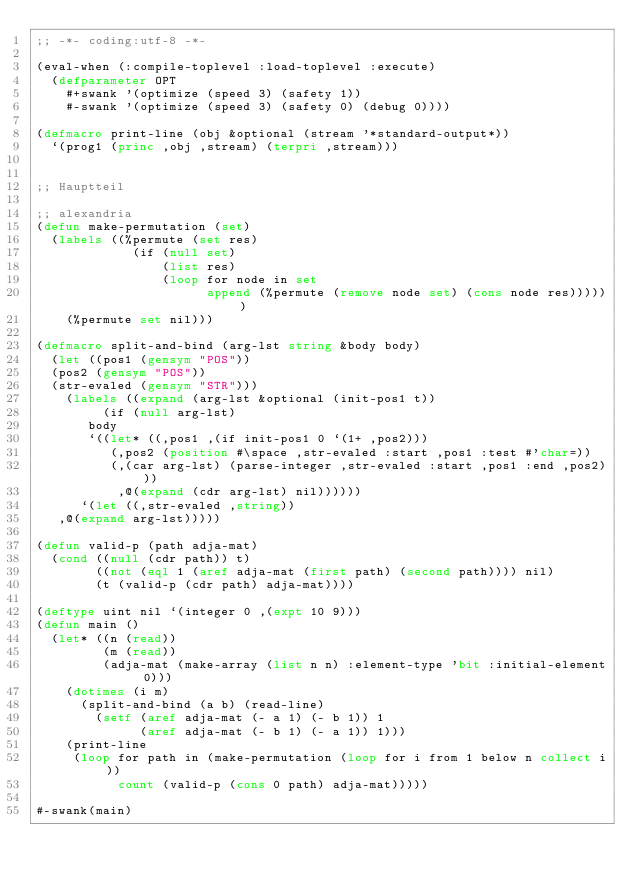Convert code to text. <code><loc_0><loc_0><loc_500><loc_500><_Lisp_>;; -*- coding:utf-8 -*-

(eval-when (:compile-toplevel :load-toplevel :execute)
  (defparameter OPT
    #+swank '(optimize (speed 3) (safety 1))
    #-swank '(optimize (speed 3) (safety 0) (debug 0))))

(defmacro print-line (obj &optional (stream '*standard-output*))
  `(prog1 (princ ,obj ,stream) (terpri ,stream)))


;; Hauptteil

;; alexandria
(defun make-permutation (set)
  (labels ((%permute (set res)
             (if (null set)
                 (list res)
                 (loop for node in set
                       append (%permute (remove node set) (cons node res))))))
    (%permute set nil)))

(defmacro split-and-bind (arg-lst string &body body)
  (let ((pos1 (gensym "POS"))
	(pos2 (gensym "POS"))
	(str-evaled (gensym "STR")))
    (labels ((expand (arg-lst &optional (init-pos1 t))
	       (if (null arg-lst)
		   body
		   `((let* ((,pos1 ,(if init-pos1 0 `(1+ ,pos2)))
			    (,pos2 (position #\space ,str-evaled :start ,pos1 :test #'char=))
			    (,(car arg-lst) (parse-integer ,str-evaled :start ,pos1 :end ,pos2)))
		       ,@(expand (cdr arg-lst) nil))))))
      `(let ((,str-evaled ,string))
	 ,@(expand arg-lst)))))

(defun valid-p (path adja-mat)
  (cond ((null (cdr path)) t)
        ((not (eql 1 (aref adja-mat (first path) (second path)))) nil)
        (t (valid-p (cdr path) adja-mat))))

(deftype uint nil `(integer 0 ,(expt 10 9)))
(defun main ()
  (let* ((n (read))
         (m (read))
         (adja-mat (make-array (list n n) :element-type 'bit :initial-element 0)))
    (dotimes (i m)
      (split-and-bind (a b) (read-line)
        (setf (aref adja-mat (- a 1) (- b 1)) 1
              (aref adja-mat (- b 1) (- a 1)) 1)))
    (print-line
     (loop for path in (make-permutation (loop for i from 1 below n collect i))
           count (valid-p (cons 0 path) adja-mat)))))

#-swank(main)
</code> 